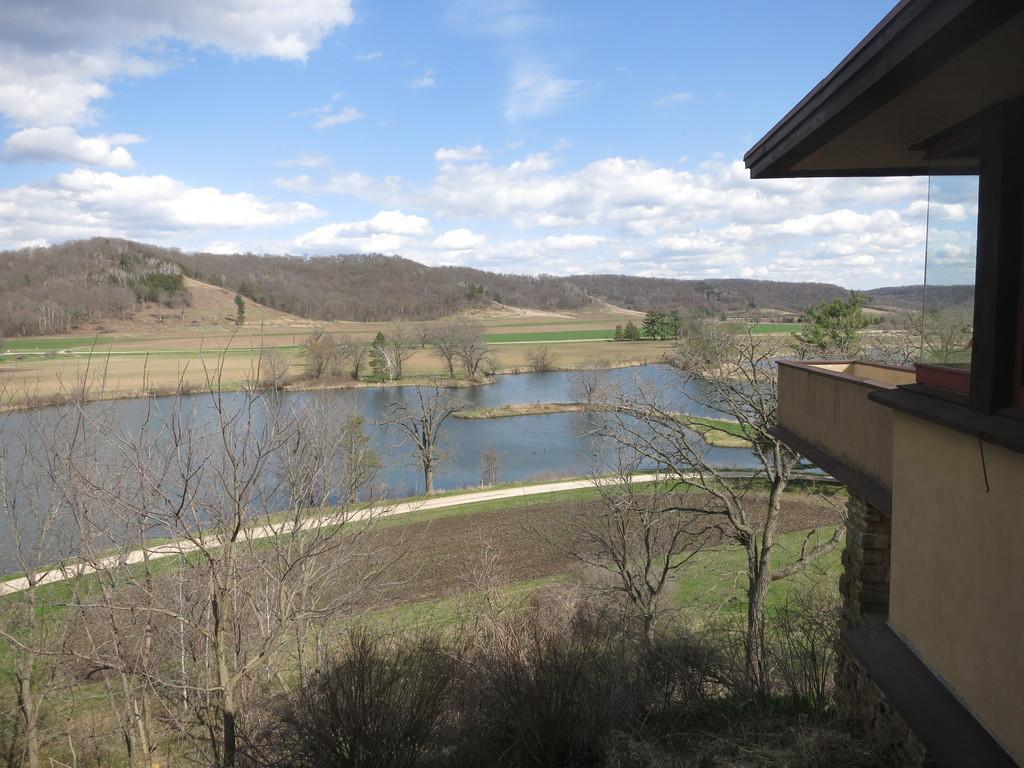Can you describe this image briefly? In this image I can see there is a building on the right side, there is a lake, few trees and in the background there are few mountains and they are covered with trees and the sky is clear. 